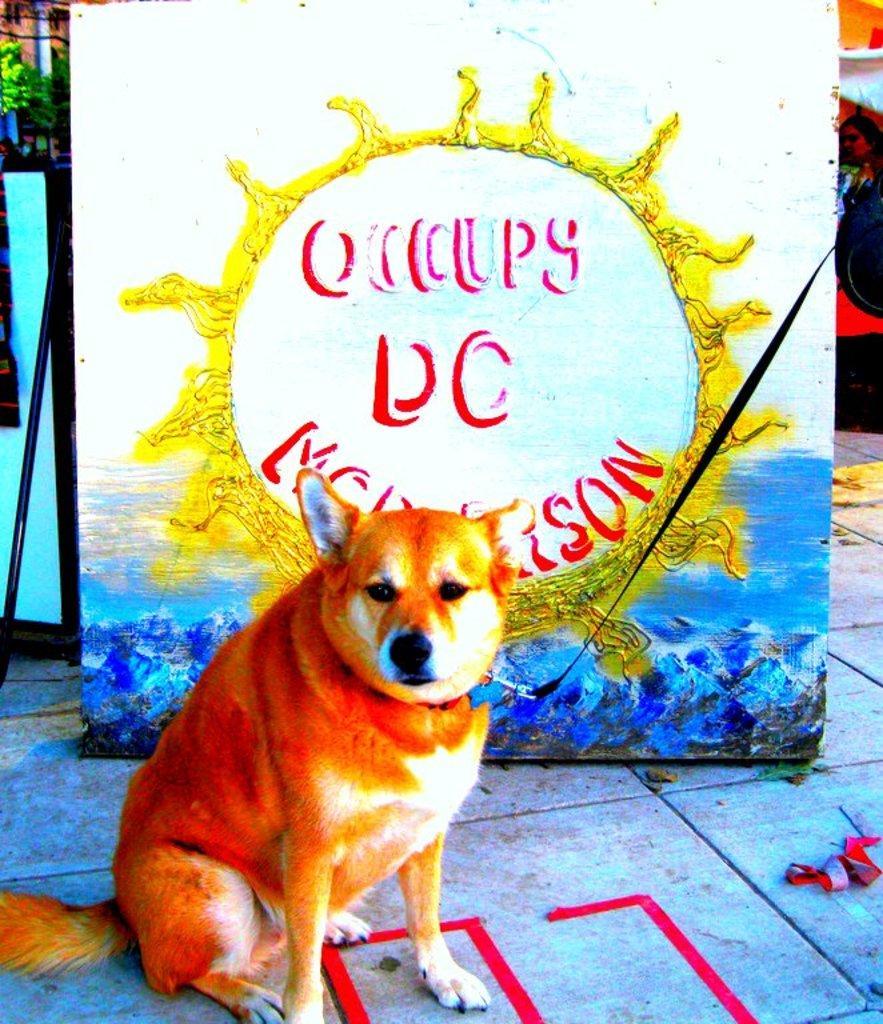In one or two sentences, can you explain what this image depicts? In this image I can see a dog and a black colour leash in the front. Behind the dog I can see a board and on it I can see something is written. On the right side of this image I can see one woman is standing and on the top left corner I can see a tree. On the bottom side of this image I can see few red colour things. 